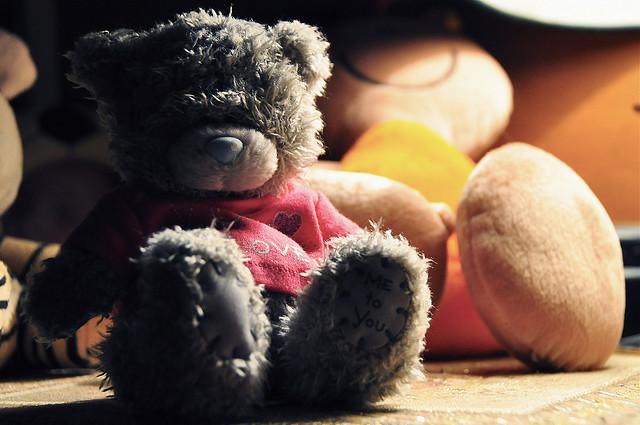What does the bear's T-shirt say?
Be succinct. Love. What color is the teddy bear?
Short answer required. Gray. Is there a light on in this room?
Quick response, please. Yes. What color is the bear?
Answer briefly. Gray. Is this a toy bear?
Answer briefly. Yes. 